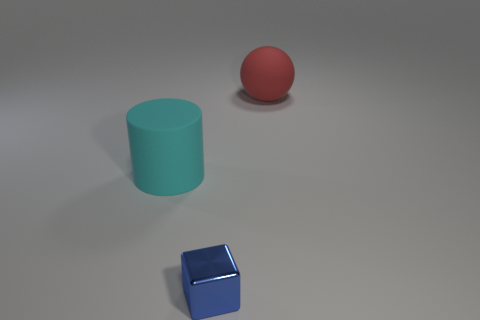Add 3 blue metallic blocks. How many objects exist? 6 Subtract all cylinders. How many objects are left? 2 Subtract 1 cyan cylinders. How many objects are left? 2 Subtract all large green matte balls. Subtract all big cyan matte cylinders. How many objects are left? 2 Add 1 small blue metallic objects. How many small blue metallic objects are left? 2 Add 2 large objects. How many large objects exist? 4 